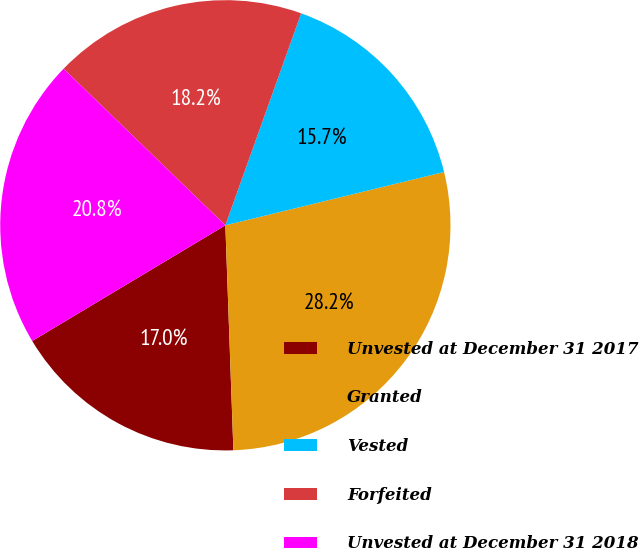Convert chart. <chart><loc_0><loc_0><loc_500><loc_500><pie_chart><fcel>Unvested at December 31 2017<fcel>Granted<fcel>Vested<fcel>Forfeited<fcel>Unvested at December 31 2018<nl><fcel>16.98%<fcel>28.24%<fcel>15.73%<fcel>18.23%<fcel>20.83%<nl></chart> 